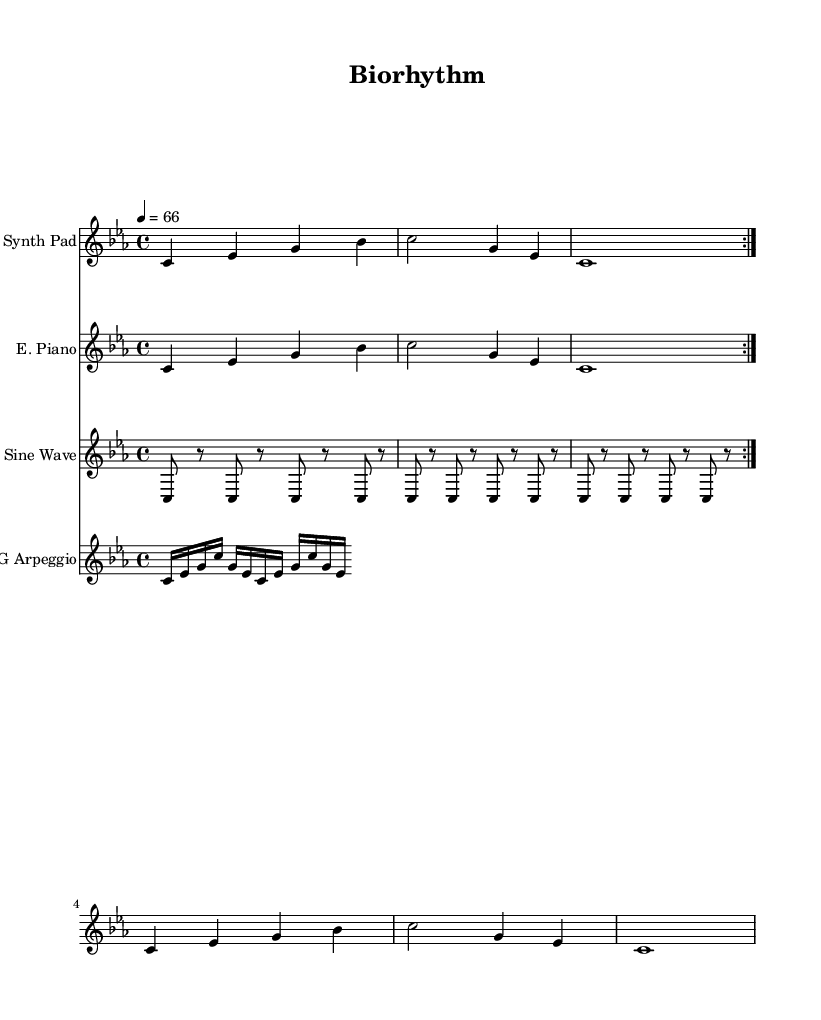What is the key signature of this music? The key signature is C minor, which has three flats: B-flat, E-flat, and A-flat. This is indicated by the 'c' in lowercase after the '\key' command in the global context.
Answer: C minor What is the time signature of this music? The time signature is 4/4, which means there are four beats in each measure and the quarter note gets one beat. This is noted in the global context with '\time 4/4'.
Answer: 4/4 What is the tempo marking for this piece? The tempo marking is 66 beats per minute, indicated by the '4 = 66' notation, where '4' represents the quarter note and '66' is the BPM.
Answer: 66 How many measures are repeated in the synthesizer part? The synthesizer part features a two-measure repetition, as indicated by the use of '\repeat volta 2' which specifies to repeat the following measures twice.
Answer: 2 measures How many times does the sine wave section repeat? The sine wave section repeats six times, as indicated by the '\repeat unfold 6' command, which specifies the section to be played six times without returning to the start.
Answer: 6 times What instruments are featured in this piece? The instruments featured are a Synth Pad, Electric Piano, Sine Wave, and ECG Arpeggio, explicitly stated in each staff section by 'instrumentName' tags.
Answer: Synth Pad, Electric Piano, Sine Wave, ECG Arpeggio What is the pattern of the ECG arpeggio section? The ECG arpeggio consists of a repeating pattern of six notes: C, E-flat, G, C, G, and E-flat, played in sixteenth notes, as seen through the notation in the ECG arpeggio staff.
Answer: C, E-flat, G, C, G, E-flat 